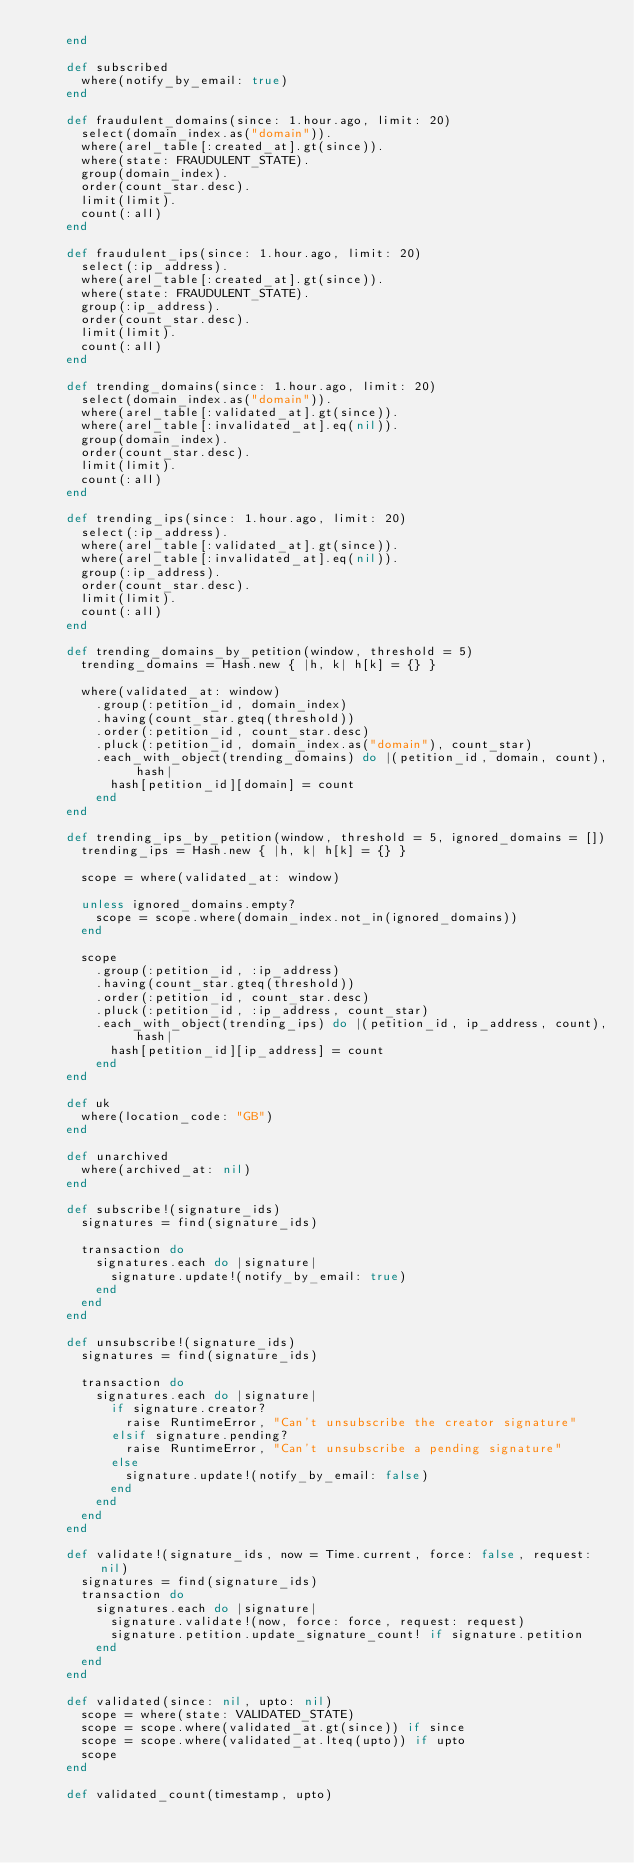<code> <loc_0><loc_0><loc_500><loc_500><_Ruby_>    end

    def subscribed
      where(notify_by_email: true)
    end

    def fraudulent_domains(since: 1.hour.ago, limit: 20)
      select(domain_index.as("domain")).
      where(arel_table[:created_at].gt(since)).
      where(state: FRAUDULENT_STATE).
      group(domain_index).
      order(count_star.desc).
      limit(limit).
      count(:all)
    end

    def fraudulent_ips(since: 1.hour.ago, limit: 20)
      select(:ip_address).
      where(arel_table[:created_at].gt(since)).
      where(state: FRAUDULENT_STATE).
      group(:ip_address).
      order(count_star.desc).
      limit(limit).
      count(:all)
    end

    def trending_domains(since: 1.hour.ago, limit: 20)
      select(domain_index.as("domain")).
      where(arel_table[:validated_at].gt(since)).
      where(arel_table[:invalidated_at].eq(nil)).
      group(domain_index).
      order(count_star.desc).
      limit(limit).
      count(:all)
    end

    def trending_ips(since: 1.hour.ago, limit: 20)
      select(:ip_address).
      where(arel_table[:validated_at].gt(since)).
      where(arel_table[:invalidated_at].eq(nil)).
      group(:ip_address).
      order(count_star.desc).
      limit(limit).
      count(:all)
    end

    def trending_domains_by_petition(window, threshold = 5)
      trending_domains = Hash.new { |h, k| h[k] = {} }

      where(validated_at: window)
        .group(:petition_id, domain_index)
        .having(count_star.gteq(threshold))
        .order(:petition_id, count_star.desc)
        .pluck(:petition_id, domain_index.as("domain"), count_star)
        .each_with_object(trending_domains) do |(petition_id, domain, count), hash|
          hash[petition_id][domain] = count
        end
    end

    def trending_ips_by_petition(window, threshold = 5, ignored_domains = [])
      trending_ips = Hash.new { |h, k| h[k] = {} }

      scope = where(validated_at: window)

      unless ignored_domains.empty?
        scope = scope.where(domain_index.not_in(ignored_domains))
      end

      scope
        .group(:petition_id, :ip_address)
        .having(count_star.gteq(threshold))
        .order(:petition_id, count_star.desc)
        .pluck(:petition_id, :ip_address, count_star)
        .each_with_object(trending_ips) do |(petition_id, ip_address, count), hash|
          hash[petition_id][ip_address] = count
        end
    end

    def uk
      where(location_code: "GB")
    end

    def unarchived
      where(archived_at: nil)
    end

    def subscribe!(signature_ids)
      signatures = find(signature_ids)

      transaction do
        signatures.each do |signature|
          signature.update!(notify_by_email: true)
        end
      end
    end

    def unsubscribe!(signature_ids)
      signatures = find(signature_ids)

      transaction do
        signatures.each do |signature|
          if signature.creator?
            raise RuntimeError, "Can't unsubscribe the creator signature"
          elsif signature.pending?
            raise RuntimeError, "Can't unsubscribe a pending signature"
          else
            signature.update!(notify_by_email: false)
          end
        end
      end
    end

    def validate!(signature_ids, now = Time.current, force: false, request: nil)
      signatures = find(signature_ids)
      transaction do
        signatures.each do |signature|
          signature.validate!(now, force: force, request: request)
          signature.petition.update_signature_count! if signature.petition
        end
      end
    end

    def validated(since: nil, upto: nil)
      scope = where(state: VALIDATED_STATE)
      scope = scope.where(validated_at.gt(since)) if since
      scope = scope.where(validated_at.lteq(upto)) if upto
      scope
    end

    def validated_count(timestamp, upto)</code> 